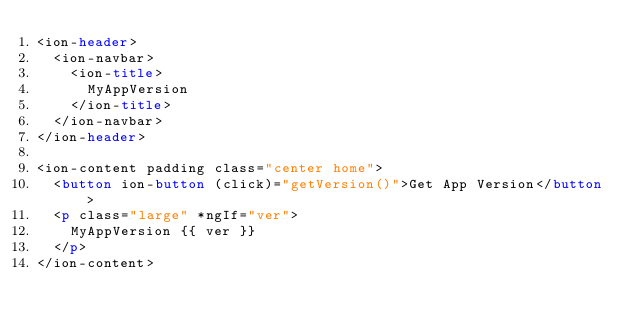<code> <loc_0><loc_0><loc_500><loc_500><_HTML_><ion-header>
  <ion-navbar>
    <ion-title>
      MyAppVersion
    </ion-title>
  </ion-navbar>
</ion-header>

<ion-content padding class="center home">
  <button ion-button (click)="getVersion()">Get App Version</button>
  <p class="large" *ngIf="ver">
    MyAppVersion {{ ver }}
  </p>
</ion-content></code> 